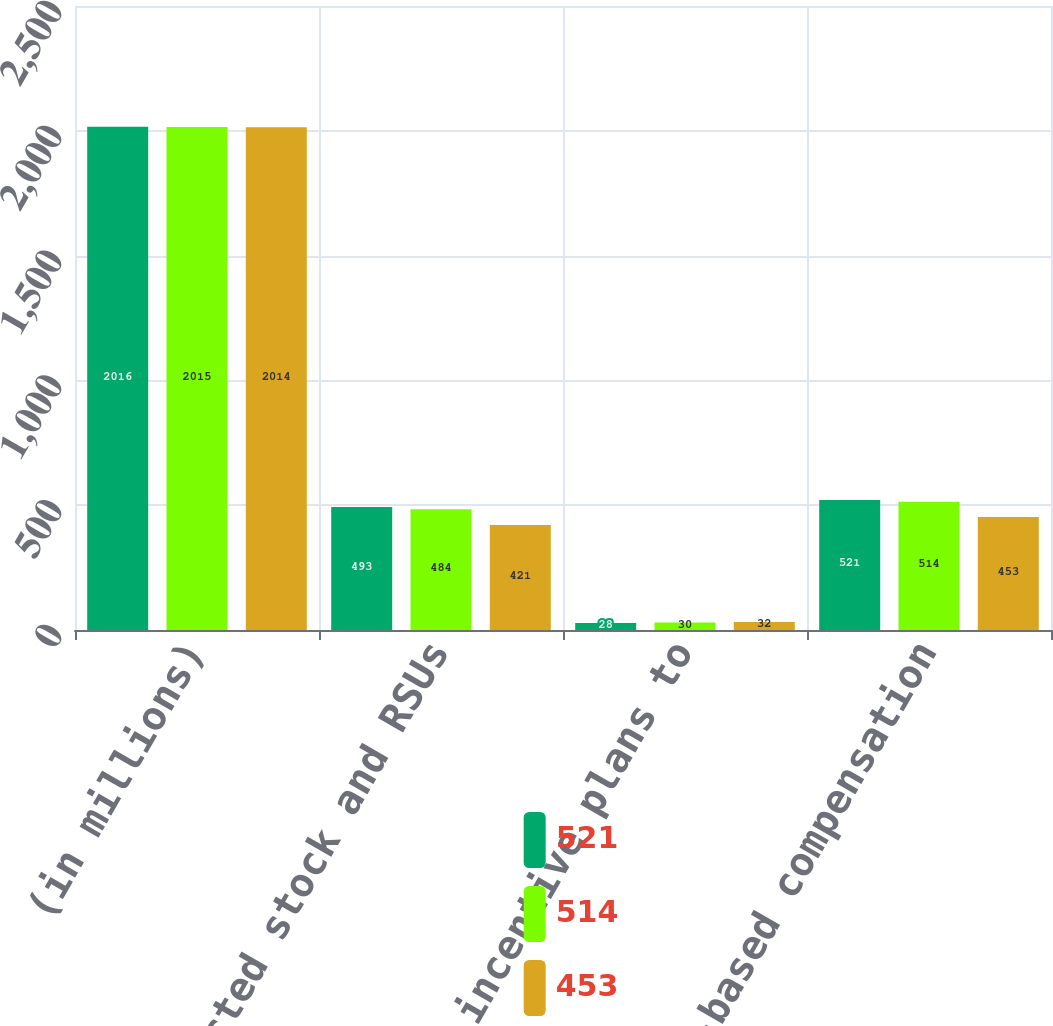Convert chart to OTSL. <chart><loc_0><loc_0><loc_500><loc_500><stacked_bar_chart><ecel><fcel>(in millions)<fcel>Restricted stock and RSUs<fcel>Long-term incentive plans to<fcel>Total stock-based compensation<nl><fcel>521<fcel>2016<fcel>493<fcel>28<fcel>521<nl><fcel>514<fcel>2015<fcel>484<fcel>30<fcel>514<nl><fcel>453<fcel>2014<fcel>421<fcel>32<fcel>453<nl></chart> 